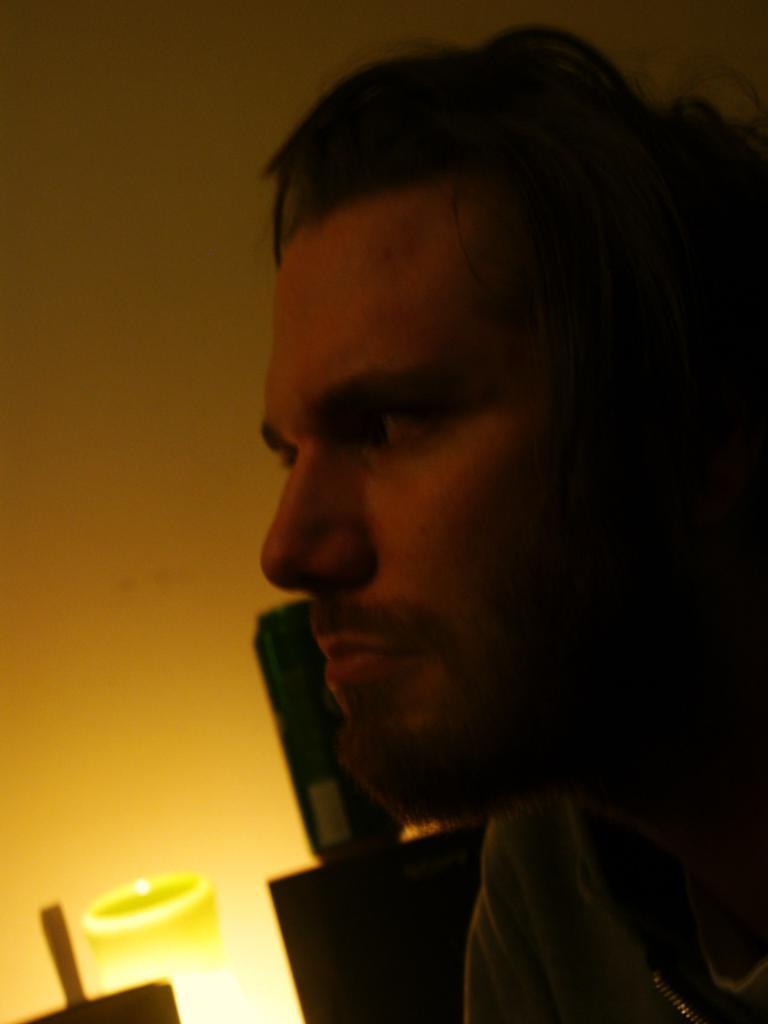Describe this image in one or two sentences. In this image we can see a person. In the background of the image there is a wall and other objects. 